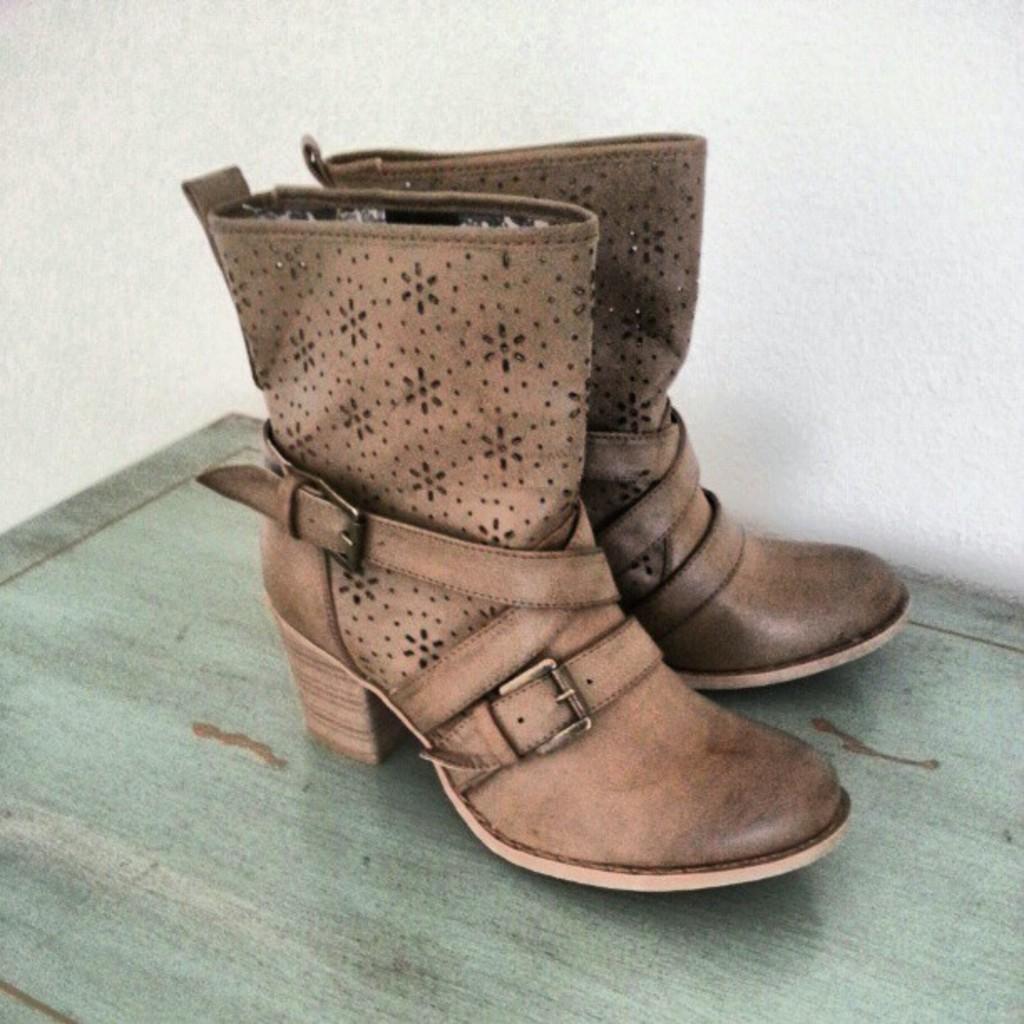Could you give a brief overview of what you see in this image? In this picture we can see shoes. 